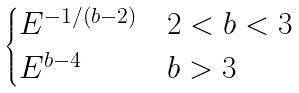Convert formula to latex. <formula><loc_0><loc_0><loc_500><loc_500>\begin{cases} E ^ { - 1 / ( b - 2 ) } & 2 < b < 3 \\ E ^ { b - 4 } & b > 3 \end{cases}</formula> 